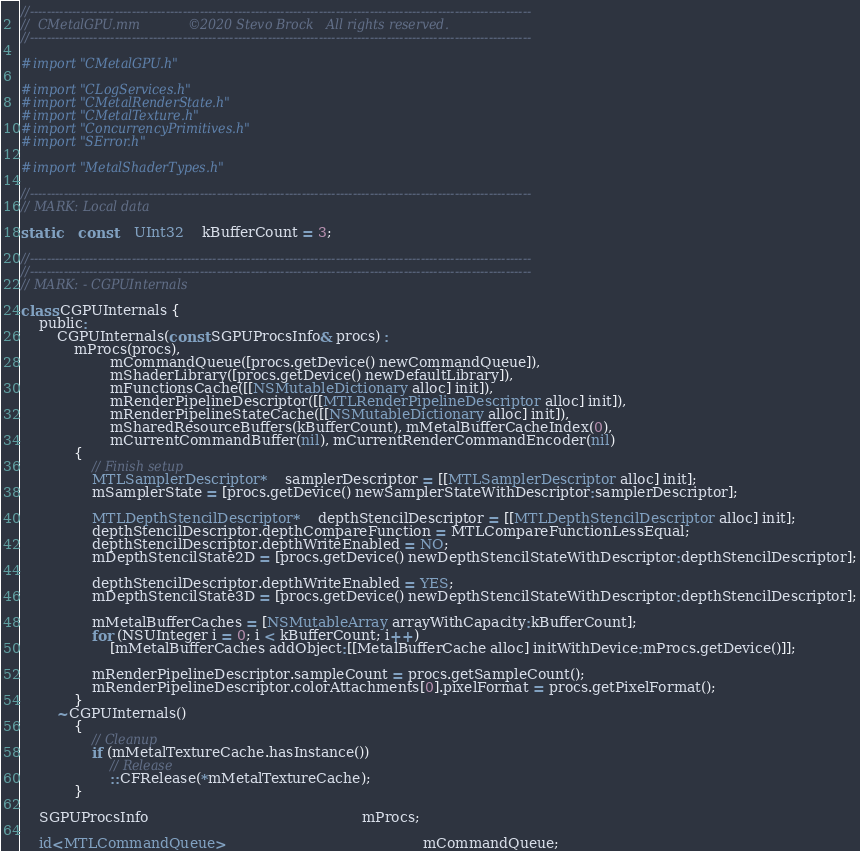Convert code to text. <code><loc_0><loc_0><loc_500><loc_500><_ObjectiveC_>//----------------------------------------------------------------------------------------------------------------------
//	CMetalGPU.mm			©2020 Stevo Brock	All rights reserved.
//----------------------------------------------------------------------------------------------------------------------

#import "CMetalGPU.h"

#import "CLogServices.h"
#import "CMetalRenderState.h"
#import "CMetalTexture.h"
#import "ConcurrencyPrimitives.h"
#import "SError.h"

#import "MetalShaderTypes.h"

//----------------------------------------------------------------------------------------------------------------------
// MARK: Local data

static	const	UInt32	kBufferCount = 3;

//----------------------------------------------------------------------------------------------------------------------
//----------------------------------------------------------------------------------------------------------------------
// MARK: - CGPUInternals

class CGPUInternals {
	public:
		CGPUInternals(const SGPUProcsInfo& procs) :
			mProcs(procs),
					mCommandQueue([procs.getDevice() newCommandQueue]),
					mShaderLibrary([procs.getDevice() newDefaultLibrary]),
					mFunctionsCache([[NSMutableDictionary alloc] init]),
					mRenderPipelineDescriptor([[MTLRenderPipelineDescriptor alloc] init]),
					mRenderPipelineStateCache([[NSMutableDictionary alloc] init]),
					mSharedResourceBuffers(kBufferCount), mMetalBufferCacheIndex(0),
					mCurrentCommandBuffer(nil), mCurrentRenderCommandEncoder(nil)
			{
				// Finish setup
				MTLSamplerDescriptor*	samplerDescriptor = [[MTLSamplerDescriptor alloc] init];
				mSamplerState = [procs.getDevice() newSamplerStateWithDescriptor:samplerDescriptor];

				MTLDepthStencilDescriptor*	depthStencilDescriptor = [[MTLDepthStencilDescriptor alloc] init];
				depthStencilDescriptor.depthCompareFunction = MTLCompareFunctionLessEqual;
				depthStencilDescriptor.depthWriteEnabled = NO;
				mDepthStencilState2D = [procs.getDevice() newDepthStencilStateWithDescriptor:depthStencilDescriptor];

				depthStencilDescriptor.depthWriteEnabled = YES;
				mDepthStencilState3D = [procs.getDevice() newDepthStencilStateWithDescriptor:depthStencilDescriptor];

				mMetalBufferCaches = [NSMutableArray arrayWithCapacity:kBufferCount];
				for (NSUInteger i = 0; i < kBufferCount; i++)
					[mMetalBufferCaches addObject:[[MetalBufferCache alloc] initWithDevice:mProcs.getDevice()]];

 				mRenderPipelineDescriptor.sampleCount = procs.getSampleCount();
				mRenderPipelineDescriptor.colorAttachments[0].pixelFormat = procs.getPixelFormat();
			}
		~CGPUInternals()
			{
				// Cleanup
				if (mMetalTextureCache.hasInstance())
					// Release
					::CFRelease(*mMetalTextureCache);
			}

	SGPUProcsInfo												mProcs;

	id<MTLCommandQueue>											mCommandQueue;</code> 